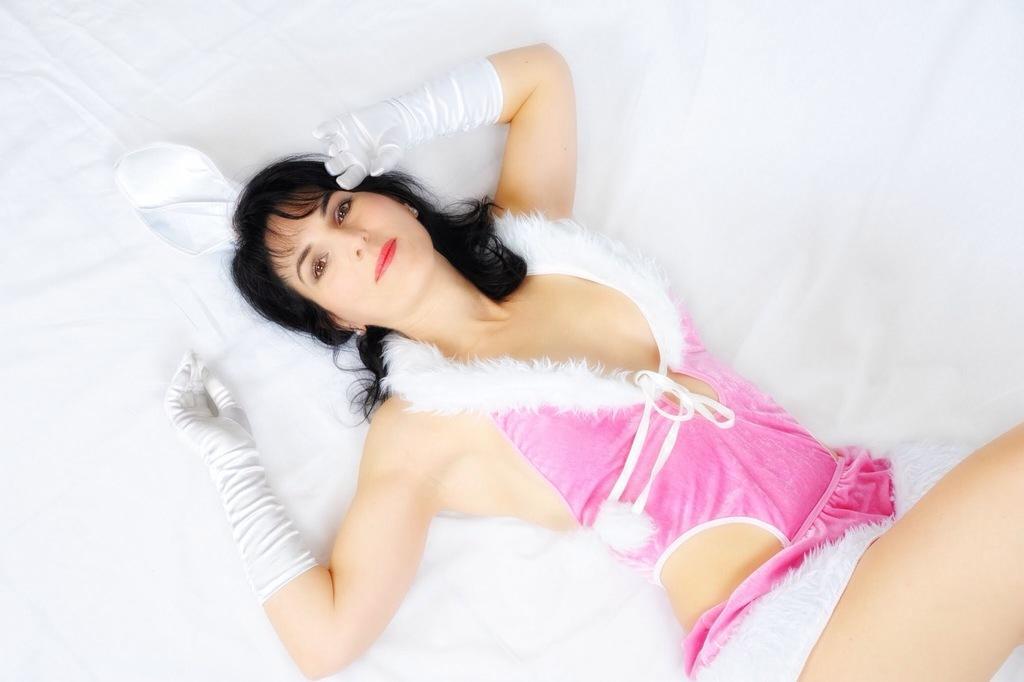Can you describe this image briefly? In the image there is a woman lying on a white cloth. 